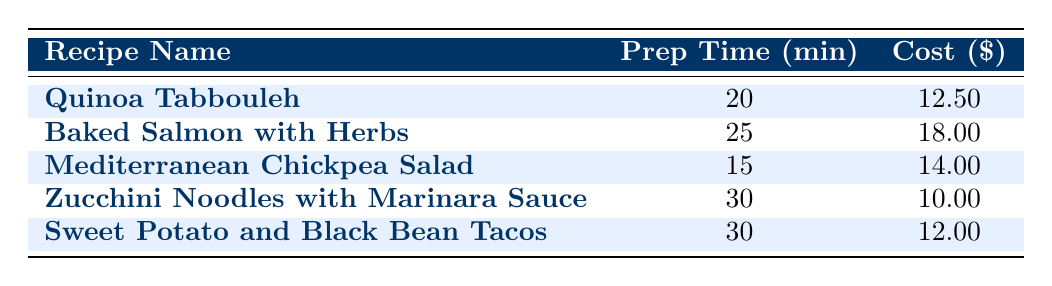What is the average preparation time for the recipes listed? To find the average preparation time, add up the preparation times for all recipes: 20 + 25 + 15 + 30 + 30 = 130 minutes. Then divide by the number of recipes, which is 5: 130/5 = 26 minutes.
Answer: 26 minutes Which recipe has the lowest ingredient cost? By inspecting the ingredient costs of each recipe, I see that the Zucchini Noodles with Marinara Sauce has the lowest cost at 10.00.
Answer: Zucchini Noodles with Marinara Sauce Is the average preparation time for Baked Salmon with Herbs more than 20 minutes? The preparation time for Baked Salmon with Herbs is 25 minutes, which is greater than 20.
Answer: Yes What is the total ingredient cost for Mediterranean Chickpea Salad? The total ingredient cost for Mediterranean Chickpea Salad is listed directly in the table as 14.00.
Answer: 14.00 Is the ingredient cost for Quinoa Tabbouleh equal to the ingredient cost for Sweet Potato and Black Bean Tacos? The ingredient cost for Quinoa Tabbouleh is 12.50, while for Sweet Potato and Black Bean Tacos it is 12.00. These values are not equal.
Answer: No What are the total preparation times for recipes that take 30 minutes? There are two recipes with a preparation time of 30 minutes: Zucchini Noodles with Marinara Sauce and Sweet Potato and Black Bean Tacos. Adding their preparation times together gives 30 + 30 = 60 minutes.
Answer: 60 minutes Which recipe has both the highest preparation time and the highest ingredient cost? The recipe with the highest preparation time is Zucchini Noodles with Marinara Sauce (30 minutes) and the highest ingredient cost is Baked Salmon with Herbs (18.00). None have both the highest of each.
Answer: None What is the difference in ingredient costs between the most expensive recipe and the least expensive recipe? The most expensive recipe is Baked Salmon with Herbs costing 18.00, and the least expensive is Zucchini Noodles with Marinara Sauce costing 10.00. The difference is 18.00 - 10.00 = 8.00.
Answer: 8.00 How many recipes take less than 25 minutes to prepare? By examining the preparation times, Quinoa Tabbouleh (20 minutes) and Mediterranean Chickpea Salad (15 minutes) take less than 25 minutes. Thus, there are 2 recipes that match this criterion.
Answer: 2 